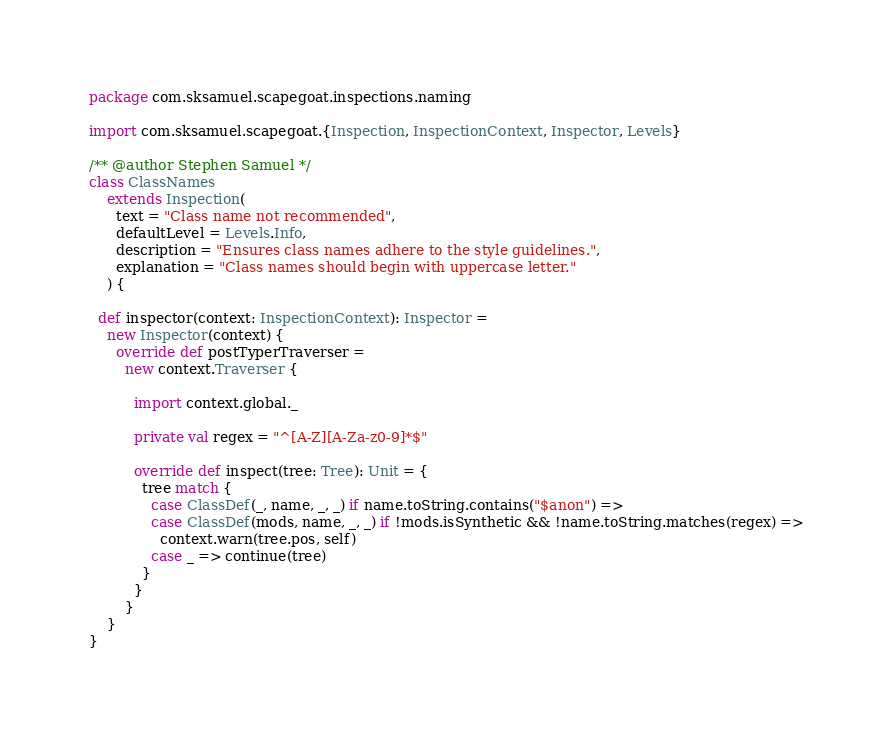Convert code to text. <code><loc_0><loc_0><loc_500><loc_500><_Scala_>package com.sksamuel.scapegoat.inspections.naming

import com.sksamuel.scapegoat.{Inspection, InspectionContext, Inspector, Levels}

/** @author Stephen Samuel */
class ClassNames
    extends Inspection(
      text = "Class name not recommended",
      defaultLevel = Levels.Info,
      description = "Ensures class names adhere to the style guidelines.",
      explanation = "Class names should begin with uppercase letter."
    ) {

  def inspector(context: InspectionContext): Inspector =
    new Inspector(context) {
      override def postTyperTraverser =
        new context.Traverser {

          import context.global._

          private val regex = "^[A-Z][A-Za-z0-9]*$"

          override def inspect(tree: Tree): Unit = {
            tree match {
              case ClassDef(_, name, _, _) if name.toString.contains("$anon") =>
              case ClassDef(mods, name, _, _) if !mods.isSynthetic && !name.toString.matches(regex) =>
                context.warn(tree.pos, self)
              case _ => continue(tree)
            }
          }
        }
    }
}
</code> 